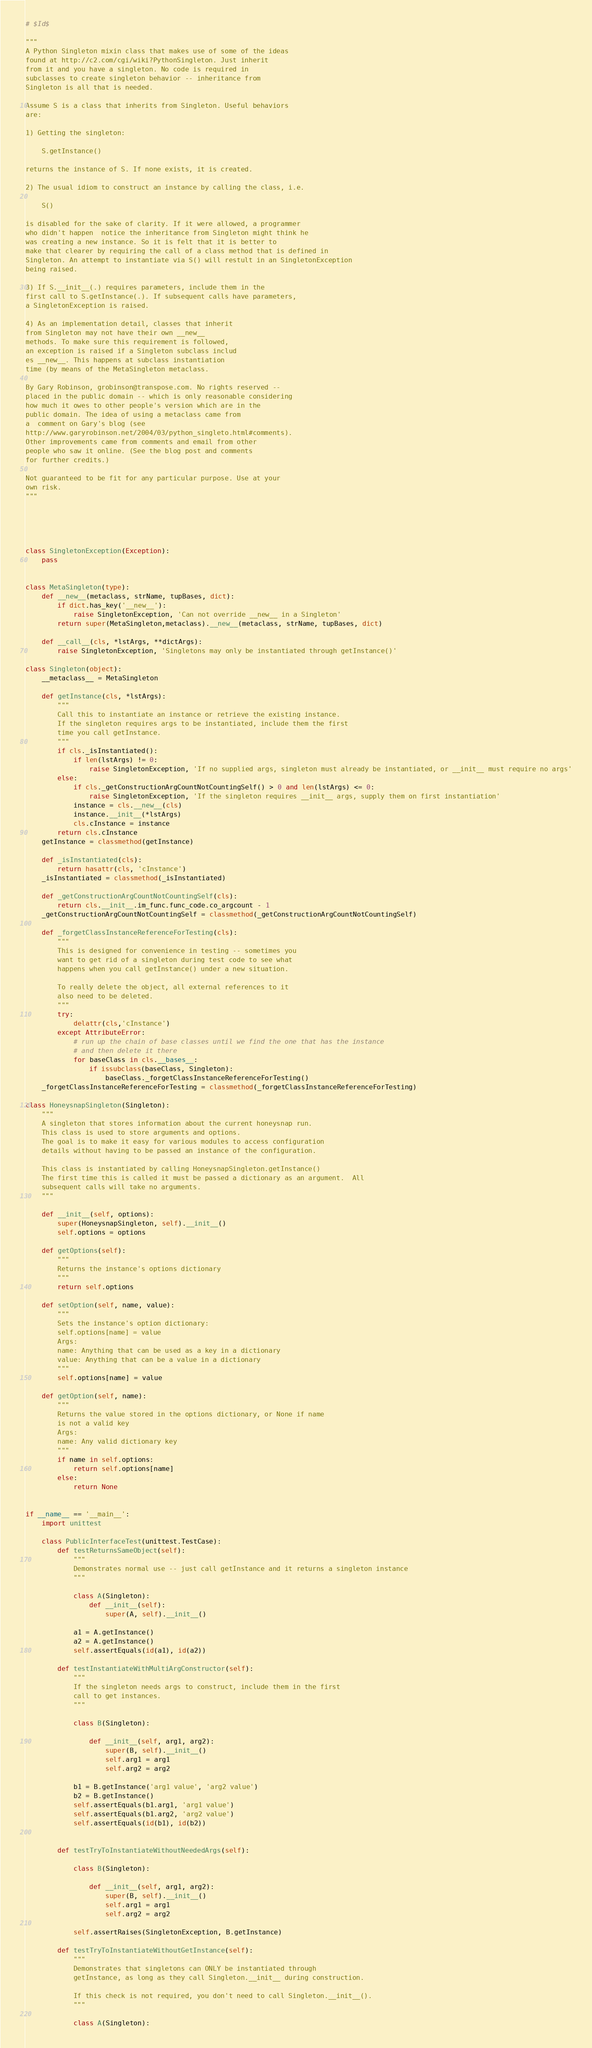Convert code to text. <code><loc_0><loc_0><loc_500><loc_500><_Python_>
# $Id$

"""
A Python Singleton mixin class that makes use of some of the ideas
found at http://c2.com/cgi/wiki?PythonSingleton. Just inherit
from it and you have a singleton. No code is required in
subclasses to create singleton behavior -- inheritance from 
Singleton is all that is needed.

Assume S is a class that inherits from Singleton. Useful behaviors
are:

1) Getting the singleton:

    S.getInstance() 
    
returns the instance of S. If none exists, it is created. 

2) The usual idiom to construct an instance by calling the class, i.e.

    S()
    
is disabled for the sake of clarity. If it were allowed, a programmer
who didn't happen  notice the inheritance from Singleton might think he
was creating a new instance. So it is felt that it is better to
make that clearer by requiring the call of a class method that is defined in
Singleton. An attempt to instantiate via S() will restult in an SingletonException
being raised.

3) If S.__init__(.) requires parameters, include them in the
first call to S.getInstance(.). If subsequent calls have parameters,
a SingletonException is raised.

4) As an implementation detail, classes that inherit 
from Singleton may not have their own __new__
methods. To make sure this requirement is followed, 
an exception is raised if a Singleton subclass includ
es __new__. This happens at subclass instantiation
time (by means of the MetaSingleton metaclass.

By Gary Robinson, grobinson@transpose.com. No rights reserved -- 
placed in the public domain -- which is only reasonable considering
how much it owes to other people's version which are in the
public domain. The idea of using a metaclass came from 
a  comment on Gary's blog (see 
http://www.garyrobinson.net/2004/03/python_singleto.html#comments). 
Other improvements came from comments and email from other
people who saw it online. (See the blog post and comments
for further credits.)

Not guaranteed to be fit for any particular purpose. Use at your
own risk. 
"""





class SingletonException(Exception):
    pass


class MetaSingleton(type):
    def __new__(metaclass, strName, tupBases, dict):
        if dict.has_key('__new__'):
            raise SingletonException, 'Can not override __new__ in a Singleton'
        return super(MetaSingleton,metaclass).__new__(metaclass, strName, tupBases, dict)
        
    def __call__(cls, *lstArgs, **dictArgs):
        raise SingletonException, 'Singletons may only be instantiated through getInstance()'
        
class Singleton(object):
    __metaclass__ = MetaSingleton
    
    def getInstance(cls, *lstArgs):
        """
        Call this to instantiate an instance or retrieve the existing instance.
        If the singleton requires args to be instantiated, include them the first
        time you call getInstance.        
        """
        if cls._isInstantiated():
            if len(lstArgs) != 0:
                raise SingletonException, 'If no supplied args, singleton must already be instantiated, or __init__ must require no args'
        else:
            if cls._getConstructionArgCountNotCountingSelf() > 0 and len(lstArgs) <= 0:
                raise SingletonException, 'If the singleton requires __init__ args, supply them on first instantiation'
            instance = cls.__new__(cls)
            instance.__init__(*lstArgs)
            cls.cInstance = instance
        return cls.cInstance
    getInstance = classmethod(getInstance)
    
    def _isInstantiated(cls):
        return hasattr(cls, 'cInstance')
    _isInstantiated = classmethod(_isInstantiated)  

    def _getConstructionArgCountNotCountingSelf(cls):
        return cls.__init__.im_func.func_code.co_argcount - 1
    _getConstructionArgCountNotCountingSelf = classmethod(_getConstructionArgCountNotCountingSelf)

    def _forgetClassInstanceReferenceForTesting(cls):
        """
        This is designed for convenience in testing -- sometimes you 
        want to get rid of a singleton during test code to see what
        happens when you call getInstance() under a new situation.
        
        To really delete the object, all external references to it
        also need to be deleted.
        """
        try:
            delattr(cls,'cInstance')
        except AttributeError:
            # run up the chain of base classes until we find the one that has the instance
            # and then delete it there
            for baseClass in cls.__bases__: 
                if issubclass(baseClass, Singleton):
                    baseClass._forgetClassInstanceReferenceForTesting()
    _forgetClassInstanceReferenceForTesting = classmethod(_forgetClassInstanceReferenceForTesting)
    
class HoneysnapSingleton(Singleton):
    """
    A singleton that stores information about the current honeysnap run.
    This class is used to store arguments and options.
    The goal is to make it easy for various modules to access configuration 
    details without having to be passed an instance of the configuration.
    
    This class is instantiated by calling HoneysnapSingleton.getInstance()
    The first time this is called it must be passed a dictionary as an argument.  All
    subsequent calls will take no arguments.
    """
    
    def __init__(self, options):
        super(HoneysnapSingleton, self).__init__()
        self.options = options
        
    def getOptions(self):
        """
        Returns the instance's options dictionary
        """
        return self.options
        
    def setOption(self, name, value):
        """
        Sets the instance's option dictionary: 
        self.options[name] = value
        Args:
        name: Anything that can be used as a key in a dictionary
        value: Anything that can be a value in a dictionary
        """
        self.options[name] = value
        
    def getOption(self, name):
        """
        Returns the value stored in the options dictionary, or None if name
        is not a valid key
        Args:
        name: Any valid dictionary key
        """
        if name in self.options:
            return self.options[name]
        else:
            return None
 

if __name__ == '__main__':
    import unittest
    
    class PublicInterfaceTest(unittest.TestCase):
        def testReturnsSameObject(self):
            """
            Demonstrates normal use -- just call getInstance and it returns a singleton instance
            """
        
            class A(Singleton): 
                def __init__(self):
                    super(A, self).__init__()
                    
            a1 = A.getInstance()
            a2 = A.getInstance()
            self.assertEquals(id(a1), id(a2))
            
        def testInstantiateWithMultiArgConstructor(self):
            """
            If the singleton needs args to construct, include them in the first
            call to get instances.
            """
                    
            class B(Singleton): 
                    
                def __init__(self, arg1, arg2):
                    super(B, self).__init__()
                    self.arg1 = arg1
                    self.arg2 = arg2

            b1 = B.getInstance('arg1 value', 'arg2 value')
            b2 = B.getInstance()
            self.assertEquals(b1.arg1, 'arg1 value')
            self.assertEquals(b1.arg2, 'arg2 value')
            self.assertEquals(id(b1), id(b2))
            
            
        def testTryToInstantiateWithoutNeededArgs(self):
            
            class B(Singleton): 
                    
                def __init__(self, arg1, arg2):
                    super(B, self).__init__()
                    self.arg1 = arg1
                    self.arg2 = arg2

            self.assertRaises(SingletonException, B.getInstance)
            
        def testTryToInstantiateWithoutGetInstance(self):
            """
            Demonstrates that singletons can ONLY be instantiated through
            getInstance, as long as they call Singleton.__init__ during construction.
            
            If this check is not required, you don't need to call Singleton.__init__().
            """

            class A(Singleton): </code> 